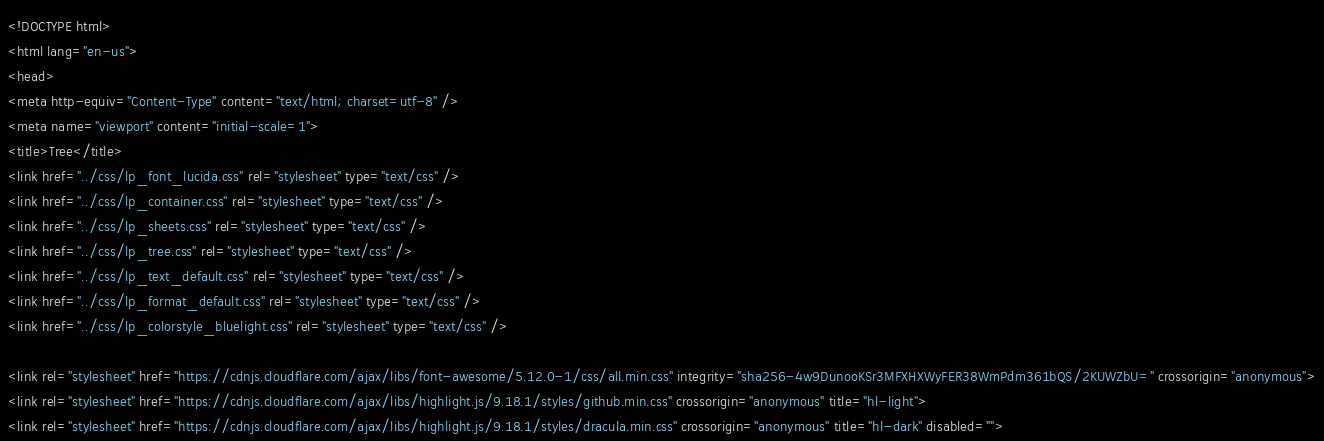<code> <loc_0><loc_0><loc_500><loc_500><_HTML_><!DOCTYPE html>
<html lang="en-us">
<head>
<meta http-equiv="Content-Type" content="text/html; charset=utf-8" />
<meta name="viewport" content="initial-scale=1">
<title>Tree</title>
<link href="../css/lp_font_lucida.css" rel="stylesheet" type="text/css" />
<link href="../css/lp_container.css" rel="stylesheet" type="text/css" />
<link href="../css/lp_sheets.css" rel="stylesheet" type="text/css" />
<link href="../css/lp_tree.css" rel="stylesheet" type="text/css" />
<link href="../css/lp_text_default.css" rel="stylesheet" type="text/css" />
<link href="../css/lp_format_default.css" rel="stylesheet" type="text/css" />
<link href="../css/lp_colorstyle_bluelight.css" rel="stylesheet" type="text/css" />

<link rel="stylesheet" href="https://cdnjs.cloudflare.com/ajax/libs/font-awesome/5.12.0-1/css/all.min.css" integrity="sha256-4w9DunooKSr3MFXHXWyFER38WmPdm361bQS/2KUWZbU=" crossorigin="anonymous">
<link rel="stylesheet" href="https://cdnjs.cloudflare.com/ajax/libs/highlight.js/9.18.1/styles/github.min.css" crossorigin="anonymous" title="hl-light">
<link rel="stylesheet" href="https://cdnjs.cloudflare.com/ajax/libs/highlight.js/9.18.1/styles/dracula.min.css" crossorigin="anonymous" title="hl-dark" disabled=""></code> 